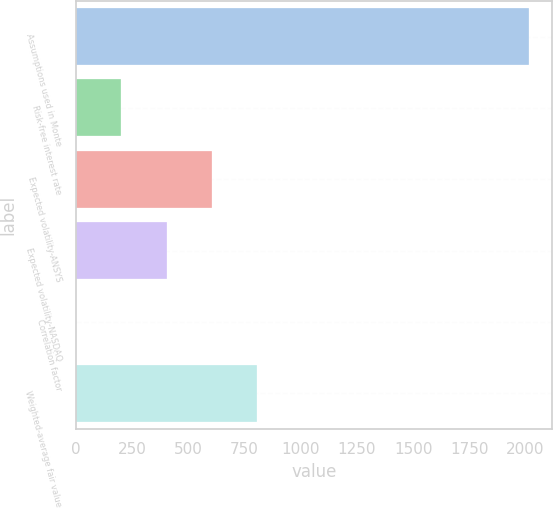<chart> <loc_0><loc_0><loc_500><loc_500><bar_chart><fcel>Assumptions used in Monte<fcel>Risk-free interest rate<fcel>Expected volatility-ANSYS<fcel>Expected volatility-NASDAQ<fcel>Correlation factor<fcel>Weighted-average fair value<nl><fcel>2016<fcel>202.19<fcel>605.26<fcel>403.73<fcel>0.65<fcel>806.79<nl></chart> 